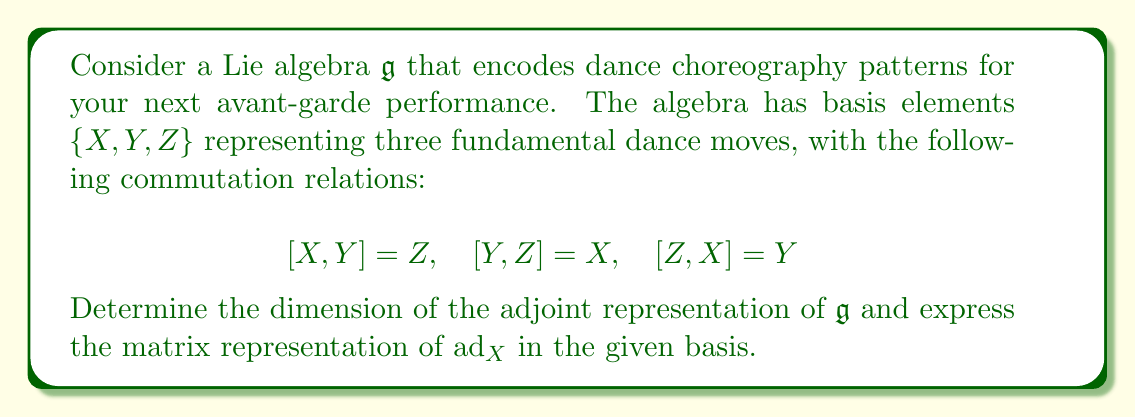Solve this math problem. To solve this problem, we'll follow these steps:

1) First, recall that the dimension of the adjoint representation of a Lie algebra is equal to the dimension of the algebra itself. In this case, we have 3 basis elements, so:

   $\dim(\text{ad}_\mathfrak{g}) = \dim(\mathfrak{g}) = 3$

2) To find the matrix representation of $\text{ad}_X$, we need to determine how $X$ acts on each basis element under the adjoint action. The adjoint action is defined by the Lie bracket:

   $\text{ad}_X(Y) = [X,Y]$

3) Let's compute this for each basis element:

   $\text{ad}_X(X) = [X,X] = 0$
   $\text{ad}_X(Y) = [X,Y] = Z$
   $\text{ad}_X(Z) = [X,Z] = -Y$ (using the anti-symmetry property of Lie brackets)

4) Now, we can express these results as linear combinations of the basis elements:

   $\text{ad}_X(X) = 0X + 0Y + 0Z$
   $\text{ad}_X(Y) = 0X + 0Y + 1Z$
   $\text{ad}_X(Z) = 0X - 1Y + 0Z$

5) The coefficients of these linear combinations form the columns of the matrix representation of $\text{ad}_X$:

   $$\text{ad}_X = \begin{pmatrix}
   0 & 0 & 0 \\
   0 & 0 & -1 \\
   0 & 1 & 0
   \end{pmatrix}$$
Answer: The dimension of the adjoint representation is 3, and the matrix representation of $\text{ad}_X$ is:

$$\text{ad}_X = \begin{pmatrix}
0 & 0 & 0 \\
0 & 0 & -1 \\
0 & 1 & 0
\end{pmatrix}$$ 